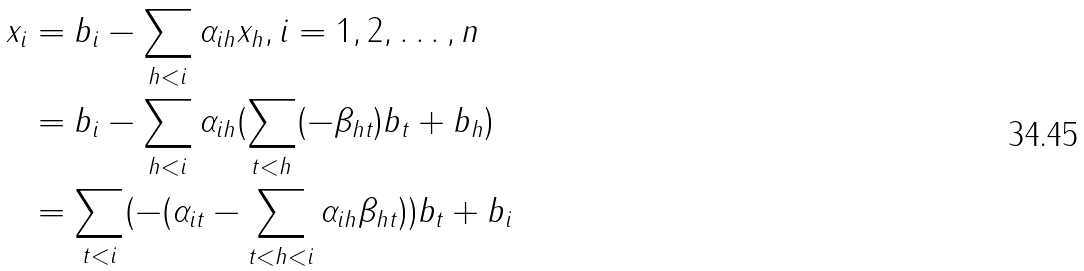Convert formula to latex. <formula><loc_0><loc_0><loc_500><loc_500>x _ { i } & = b _ { i } - \sum _ { h < i } \alpha _ { i h } x _ { h } , i = 1 , 2 , \dots , n \\ & = b _ { i } - \sum _ { h < i } \alpha _ { i h } ( \sum _ { t < h } ( - \beta _ { h t } ) b _ { t } + b _ { h } ) \\ & = \sum _ { t < i } ( - ( \alpha _ { i t } - \sum _ { t < h < i } \alpha _ { i h } \beta _ { h t } ) ) b _ { t } + b _ { i } \\</formula> 